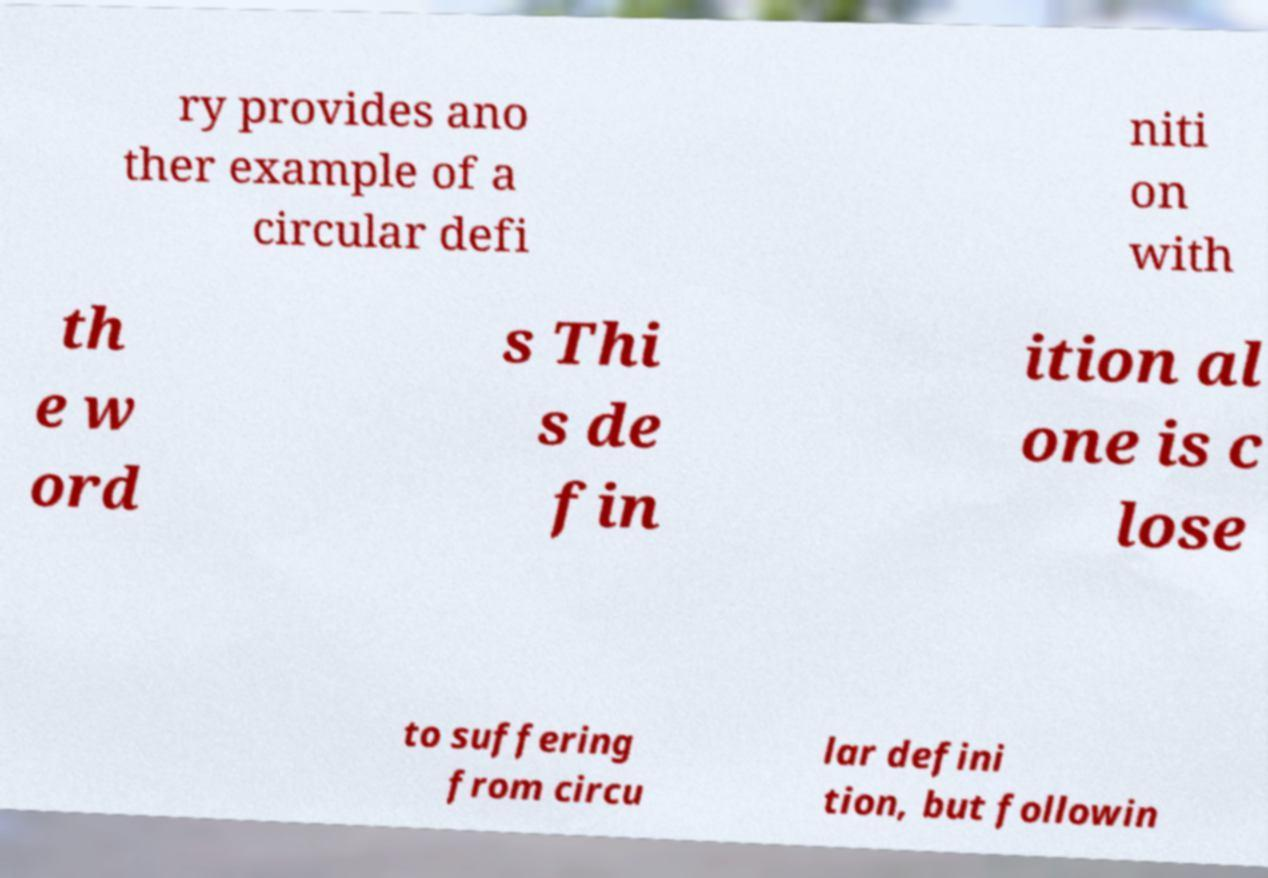Can you accurately transcribe the text from the provided image for me? ry provides ano ther example of a circular defi niti on with th e w ord s Thi s de fin ition al one is c lose to suffering from circu lar defini tion, but followin 